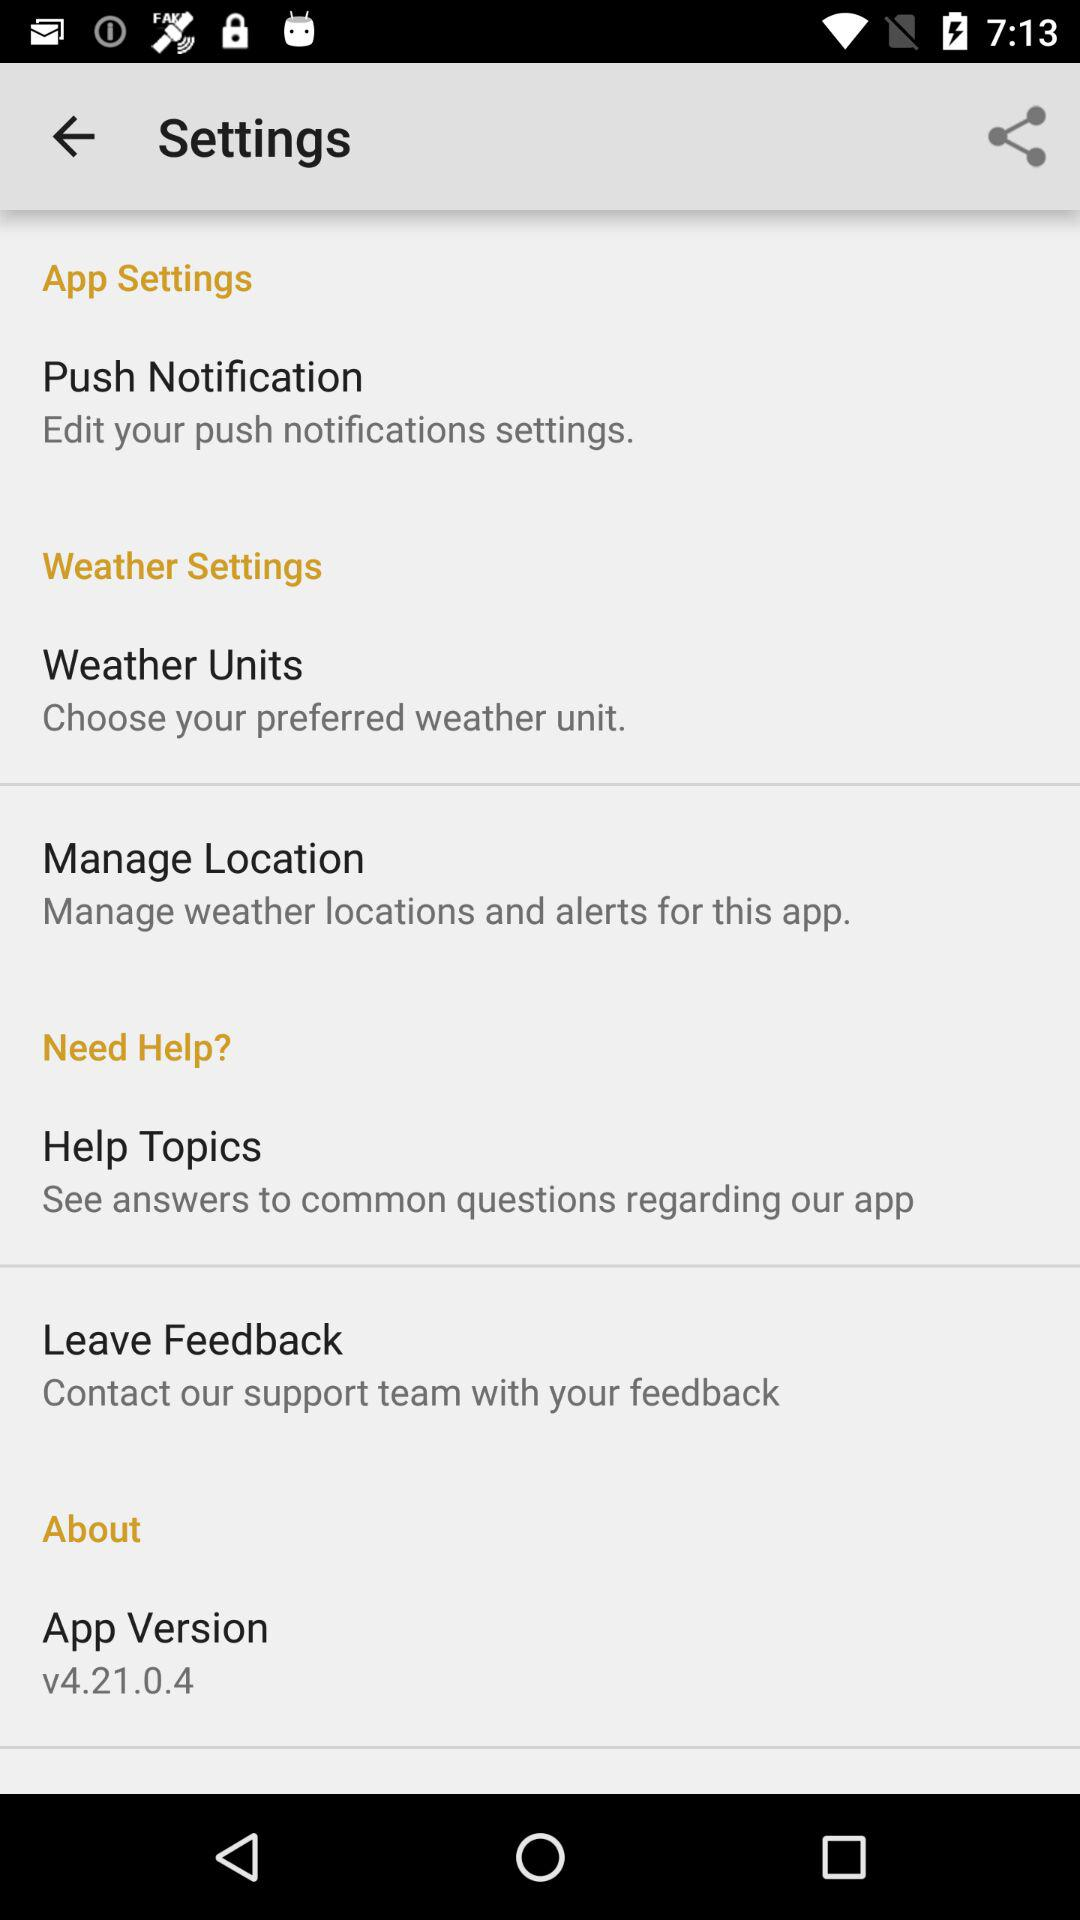Which app version is used? The used app version is v4.21.0.4. 